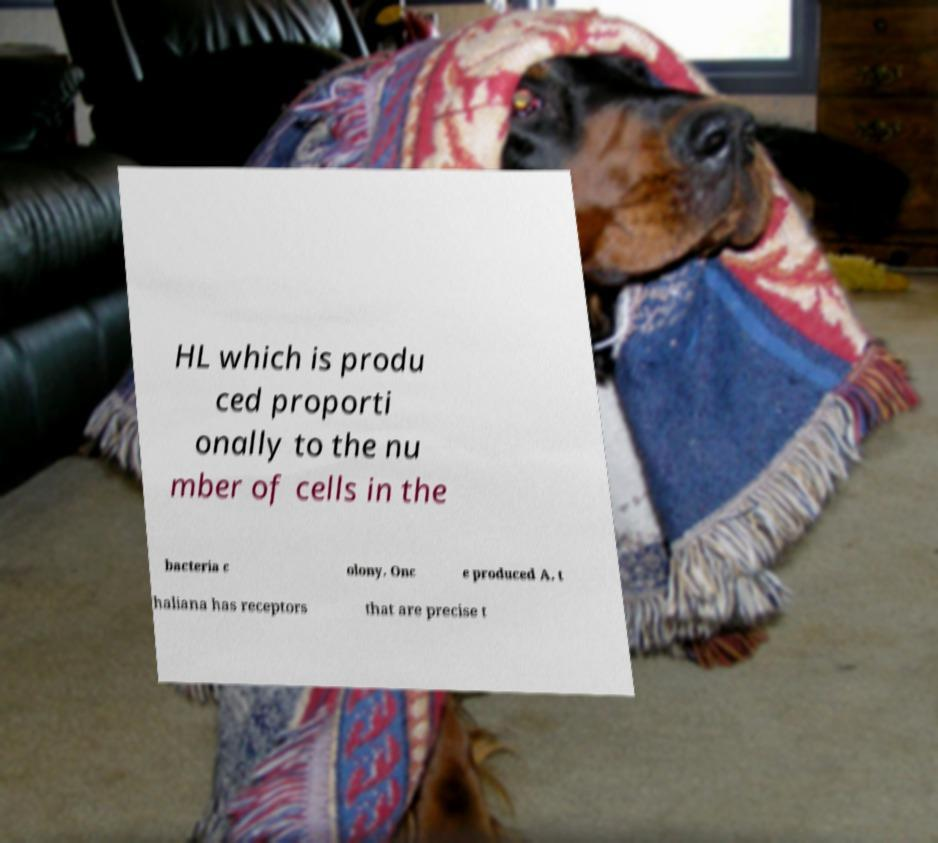Could you extract and type out the text from this image? HL which is produ ced proporti onally to the nu mber of cells in the bacteria c olony. Onc e produced A. t haliana has receptors that are precise t 